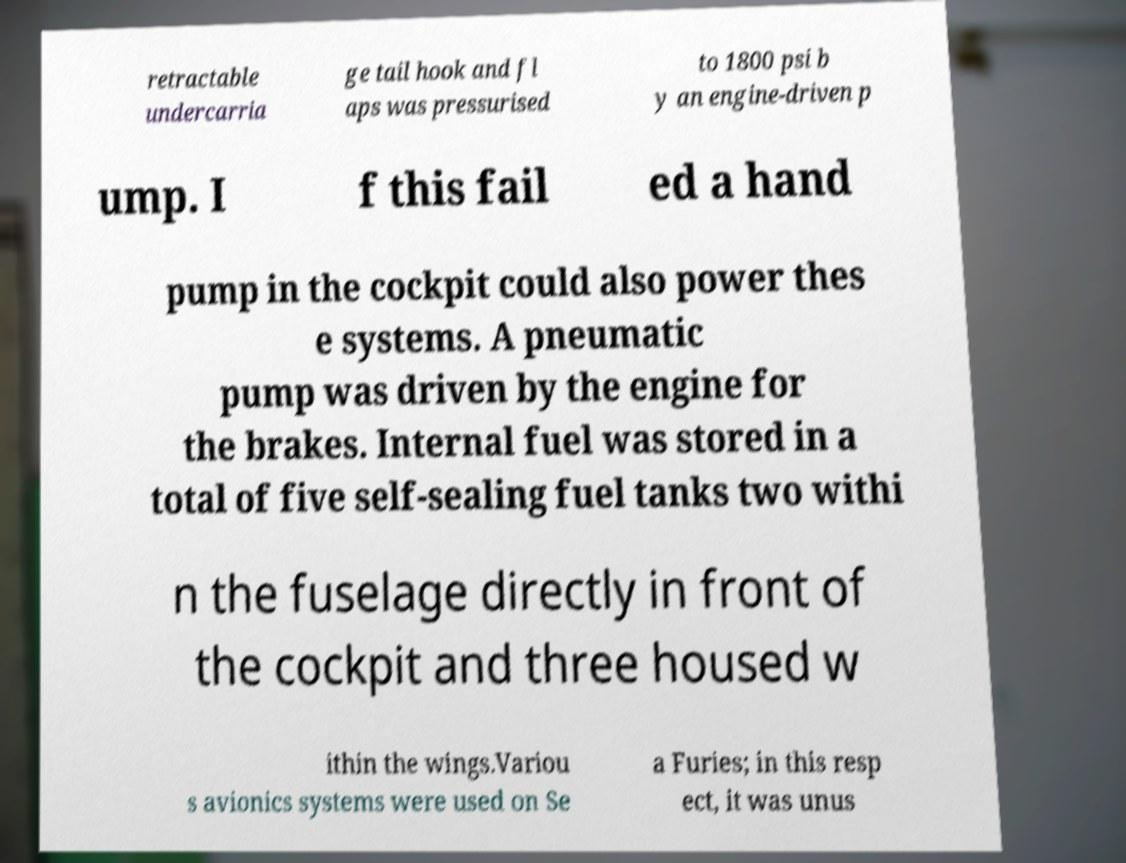Can you read and provide the text displayed in the image?This photo seems to have some interesting text. Can you extract and type it out for me? retractable undercarria ge tail hook and fl aps was pressurised to 1800 psi b y an engine-driven p ump. I f this fail ed a hand pump in the cockpit could also power thes e systems. A pneumatic pump was driven by the engine for the brakes. Internal fuel was stored in a total of five self-sealing fuel tanks two withi n the fuselage directly in front of the cockpit and three housed w ithin the wings.Variou s avionics systems were used on Se a Furies; in this resp ect, it was unus 